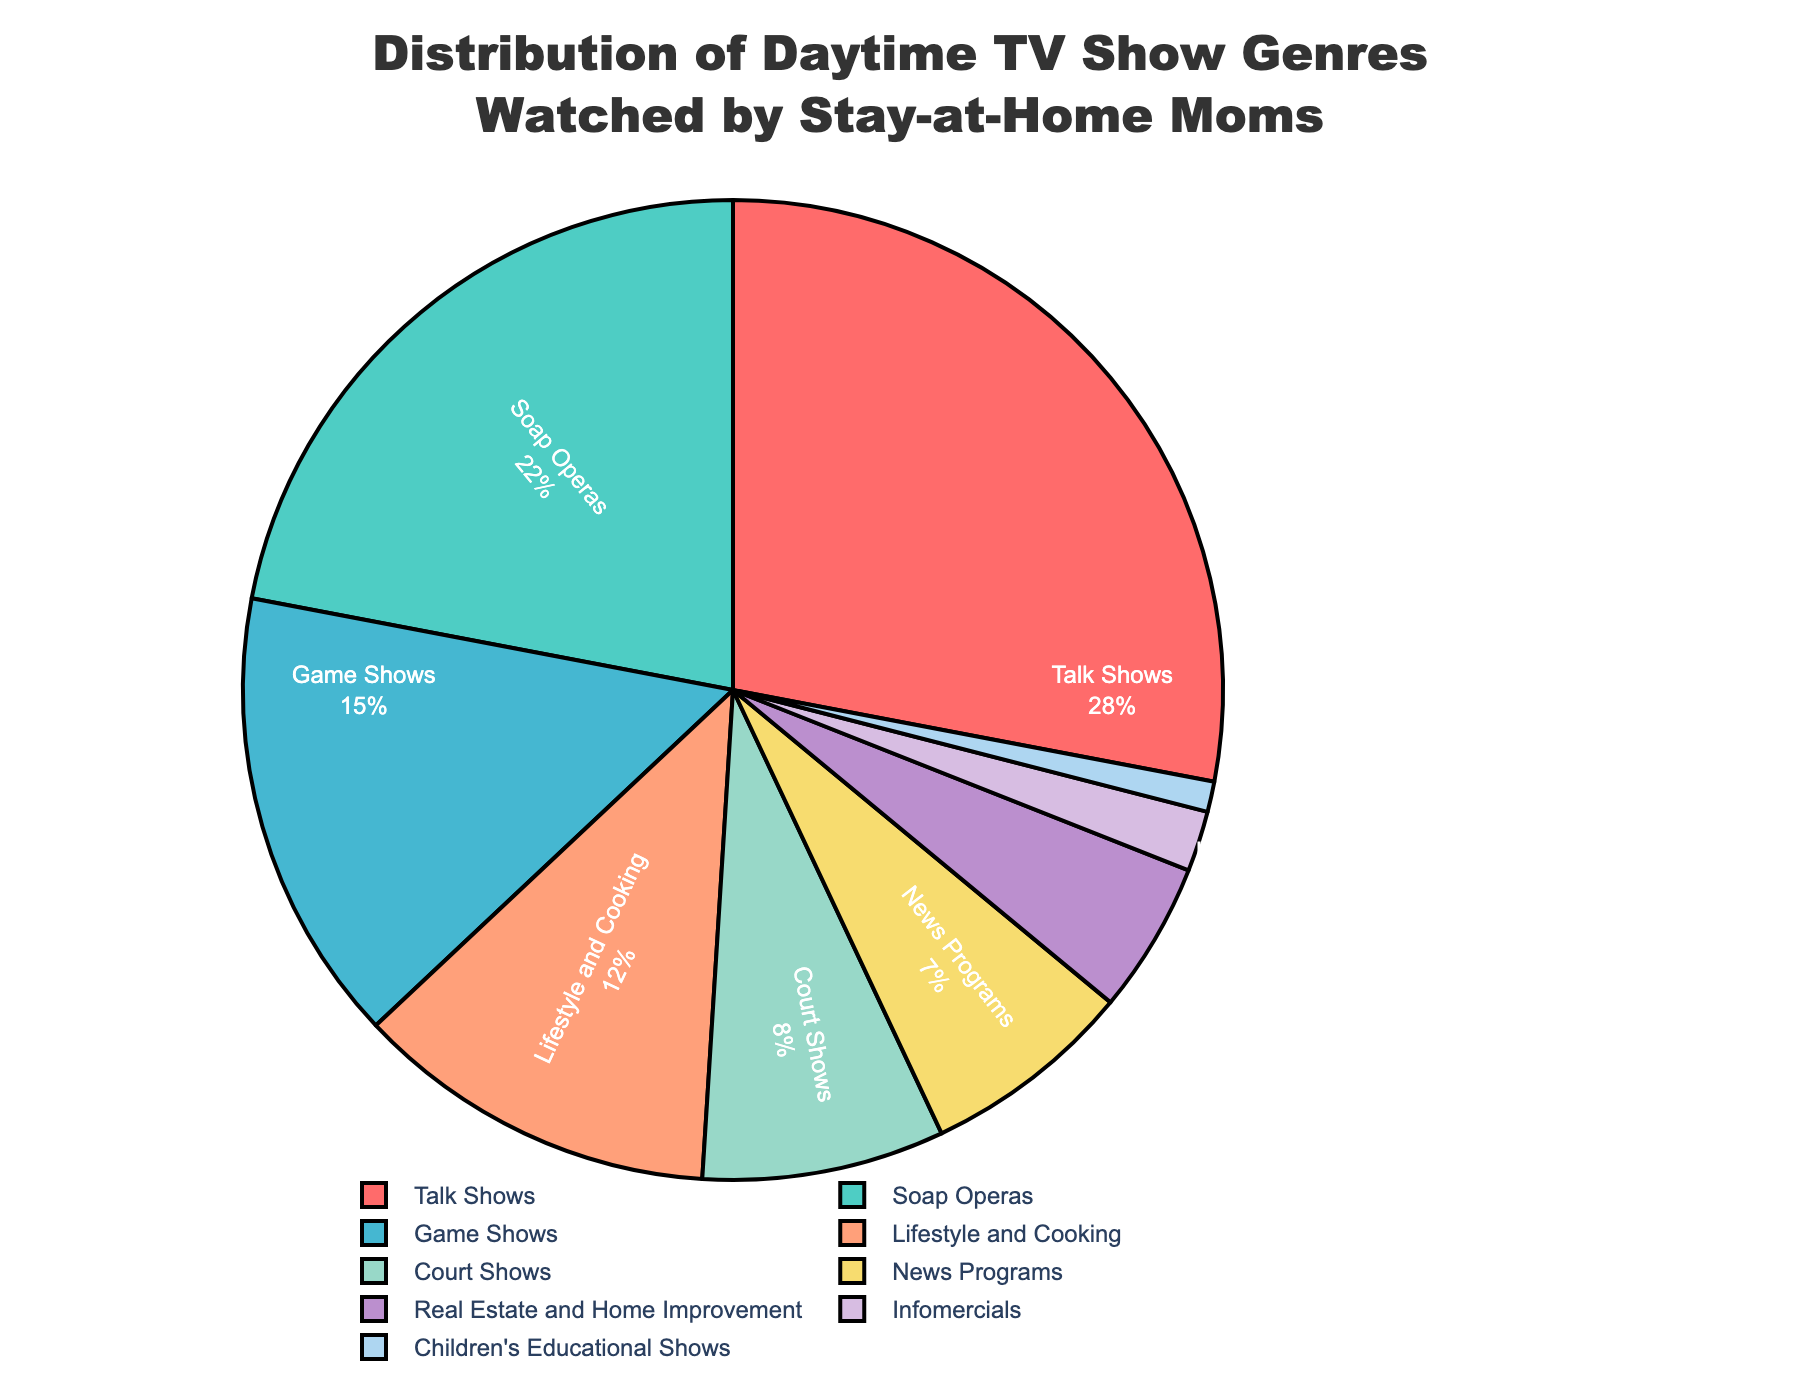What's the most watched genre among stay-at-home moms? The pie chart shows the different TV show genres and their percentages. The genre with the largest percentage is the most watched.
Answer: Talk Shows Which genre has a higher percentage, Lifestyle and Cooking or News Programs? By looking at the pie chart, we can compare the percentages directly. Lifestyle and Cooking has 12% while News Programs has 7%. So, Lifestyle and Cooking has a higher percentage.
Answer: Lifestyle and Cooking What is the combined percentage of Soap Operas and Game Shows? From the pie chart, Soap Operas are 22% and Game Shows are 15%. Adding these together gives us 22% + 15% = 37%.
Answer: 37% How much more popular are Talk Shows compared to Court Shows? Talk Shows are at 28% while Court Shows are at 8%. The difference in popularity is 28% - 8% = 20%.
Answer: 20% Are children's educational shows more or less than 5% of the total? The pie chart shows Children's Educational Shows at 1%, which is less than the 5%.
Answer: Less Which two genres combined account for a quarter of the total percentage? A quarter of the total percentage is 25%. By looking at the pie chart, Game Shows (15%) and Lifestyle and Cooking (12%) add up to 27%. However, Soap Operas (22%) and Children's Educational Shows (1%) add up to 23%, which is closer to 25%. Nevertheless, News Programs (7%) and Court Shows (8%) add up to 15%, and Game Shows (15%) are 25%.
Answer: News Programs and Court Shows What is the difference between the most-watched genre and the least-watched genre? Talk Shows are the most-watched at 28%, and Children's Educational Shows are the least-watched at 1%. The difference is 28% - 1% = 27%.
Answer: 27% What proportion of the total does Real Estate and Home Improvement represent visually? Real Estate and Home Improvement are represented with a segment that is fairly small compared to other categories and has a percentage of 5%.
Answer: 5% What is the median percentage of all the genres listed in the pie chart? To find the median, list the percentages in ascending order: 1%, 2%, 5%, 7%, 8%, 12%, 15%, 22%, 28%. The median is the middle number, which is 8%.
Answer: 8% 